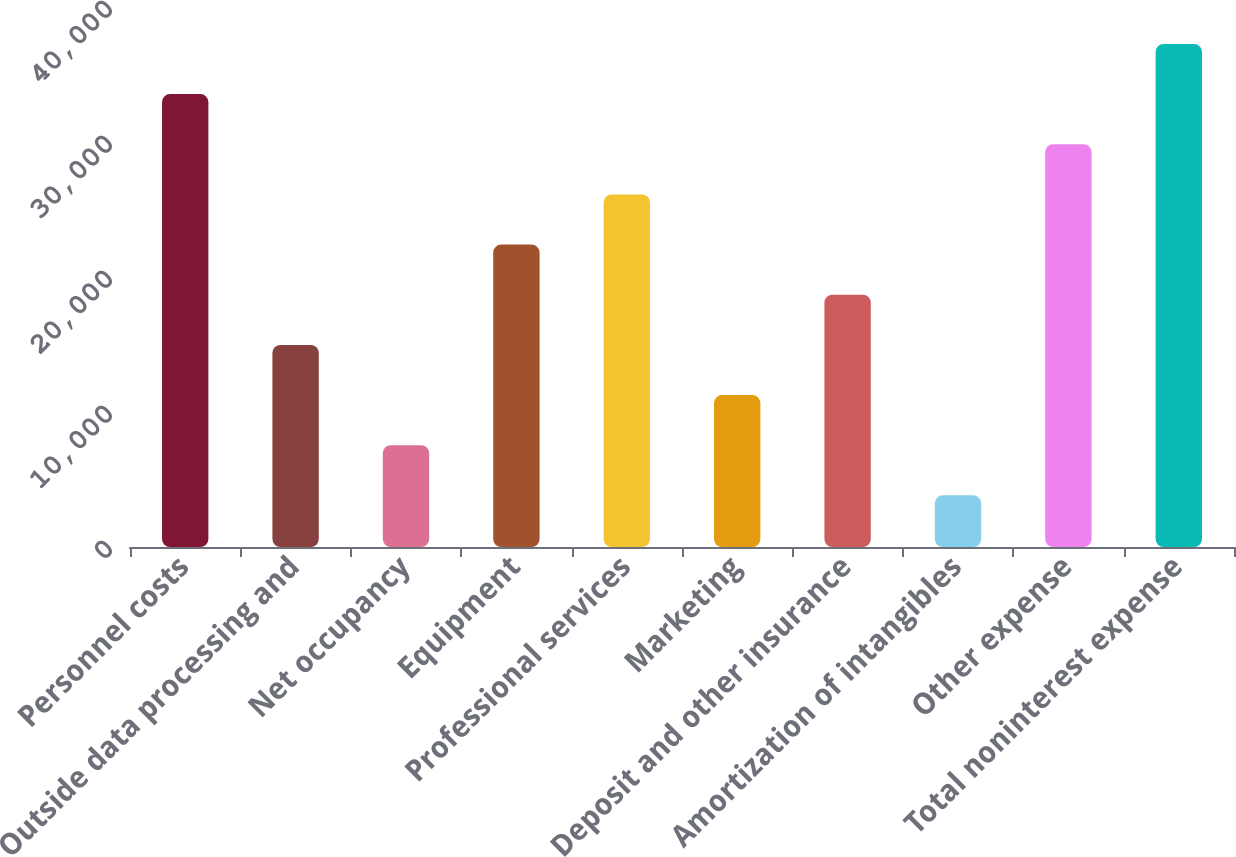<chart> <loc_0><loc_0><loc_500><loc_500><bar_chart><fcel>Personnel costs<fcel>Outside data processing and<fcel>Net occupancy<fcel>Equipment<fcel>Professional services<fcel>Marketing<fcel>Deposit and other insurance<fcel>Amortization of intangibles<fcel>Other expense<fcel>Total noninterest expense<nl><fcel>33546.8<fcel>14970.8<fcel>7540.4<fcel>22401.2<fcel>26116.4<fcel>11255.6<fcel>18686<fcel>3825.2<fcel>29831.6<fcel>37262<nl></chart> 